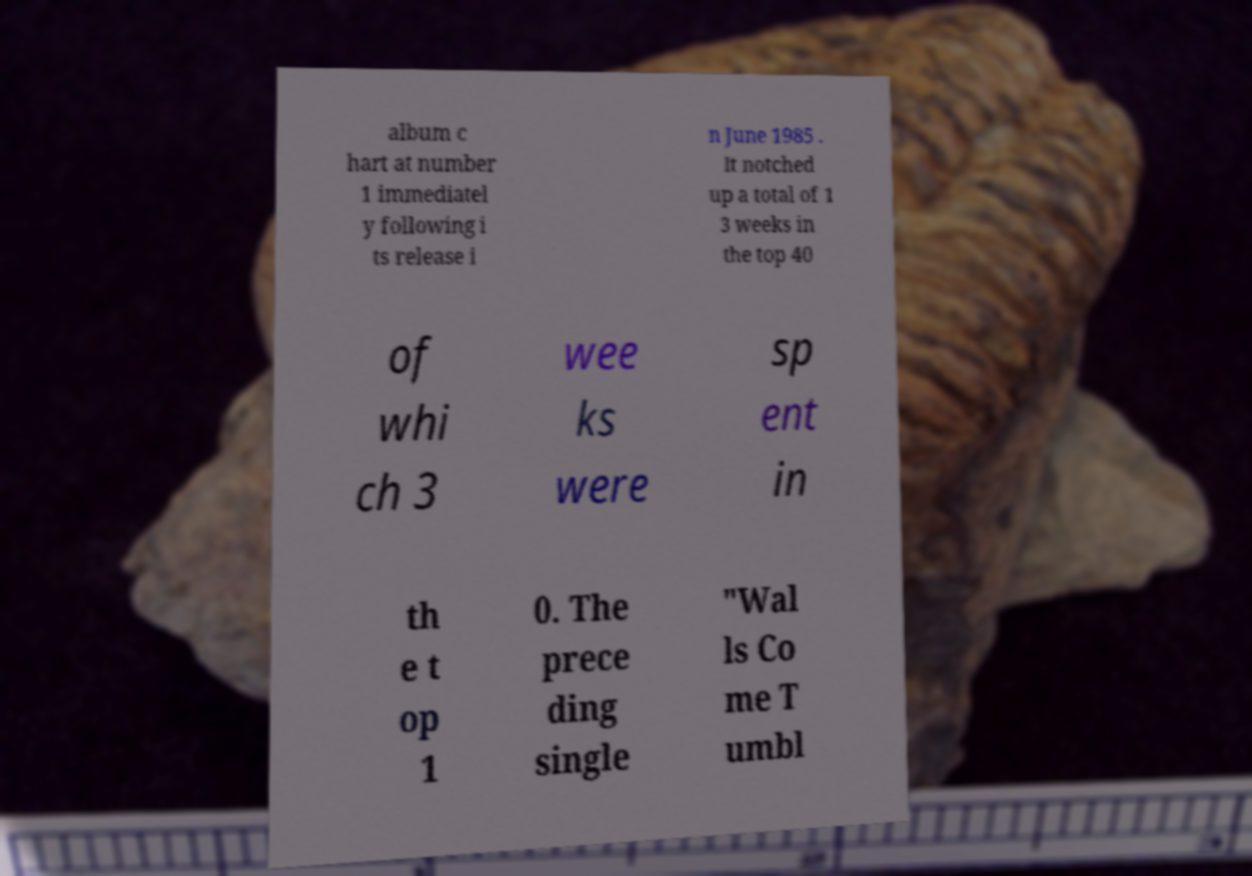Can you accurately transcribe the text from the provided image for me? album c hart at number 1 immediatel y following i ts release i n June 1985 . It notched up a total of 1 3 weeks in the top 40 of whi ch 3 wee ks were sp ent in th e t op 1 0. The prece ding single "Wal ls Co me T umbl 